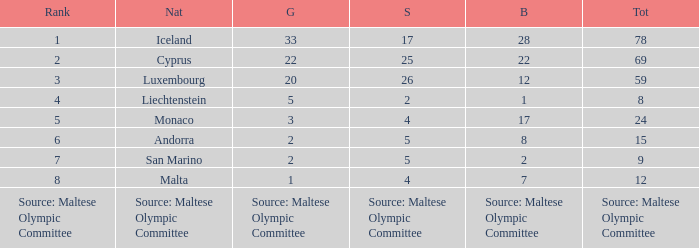What rank is the nation that has a bronze of source: Maltese Olympic Committee? Source: Maltese Olympic Committee. 